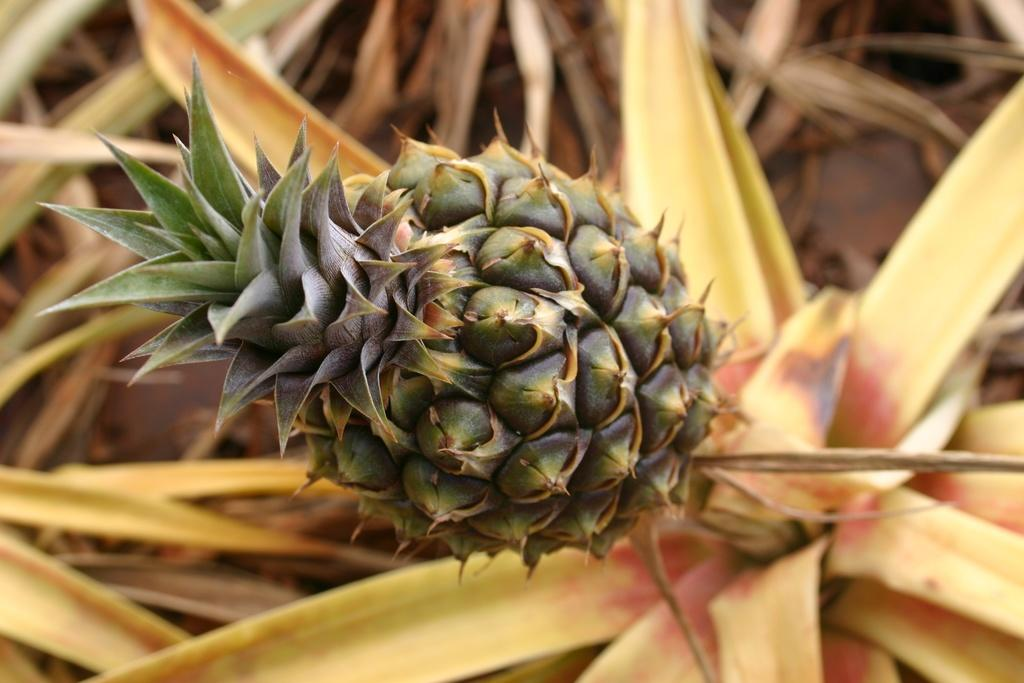What type of fruit is in the image? There is a pineapple in the image. What can be seen in the background of the image? There are leaves visible in the background of the image. What type of cheese is being used to make a profit in the image? There is no cheese or mention of profit in the image; it features a pineapple and leaves in the background. 